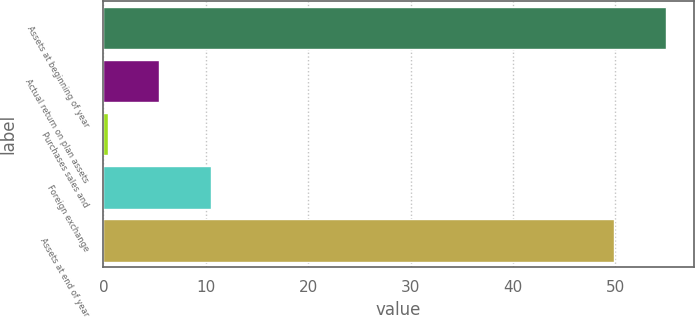Convert chart to OTSL. <chart><loc_0><loc_0><loc_500><loc_500><bar_chart><fcel>Assets at beginning of year<fcel>Actual return on plan assets<fcel>Purchases sales and<fcel>Foreign exchange<fcel>Assets at end of year<nl><fcel>54.94<fcel>5.44<fcel>0.4<fcel>10.48<fcel>49.9<nl></chart> 